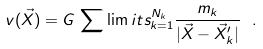Convert formula to latex. <formula><loc_0><loc_0><loc_500><loc_500>v ( \vec { X } ) = G \, \sum \lim i t s _ { k = 1 } ^ { N _ { k } } \frac { m _ { k } } { | \vec { X } - \vec { X } ^ { \prime } _ { k } | } \ .</formula> 